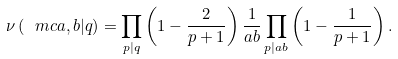<formula> <loc_0><loc_0><loc_500><loc_500>\nu \left ( \ m c { a , b | q } \right ) = \prod _ { p | q } \left ( 1 - \frac { 2 } { p + 1 } \right ) \frac { 1 } { a b } \prod _ { p | a b } \left ( 1 - \frac { 1 } { p + 1 } \right ) .</formula> 